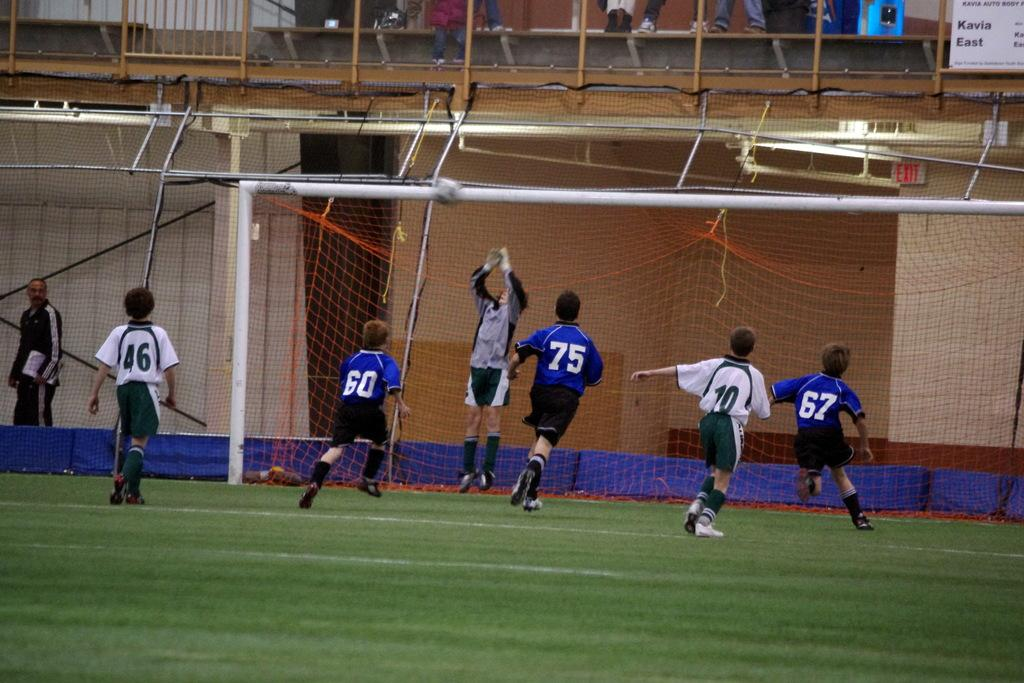What are the people in the image doing? The people in the image are playing in the ground. What can be seen in the background of the image? In the background, there is a mesh, rods, boards, and other people. Can you describe the objects in the background? The background features a mesh, rods, and boards. Are there any other people visible in the image? Yes, there are people in the background. What type of cherry is being used as a ball in the game? There is no cherry present in the image, and no indication that a cherry is being used as a ball in the game. 